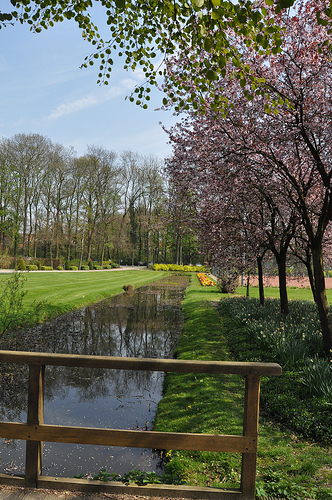<image>
Is there a tree on the water? No. The tree is not positioned on the water. They may be near each other, but the tree is not supported by or resting on top of the water. 